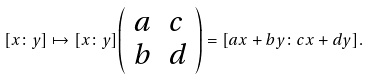<formula> <loc_0><loc_0><loc_500><loc_500>[ x \colon y ] \mapsto [ x \colon y ] { \left ( \begin{array} { l l } { a } & { c } \\ { b } & { d } \end{array} \right ) } = [ a x + b y \colon c x + d y ] .</formula> 